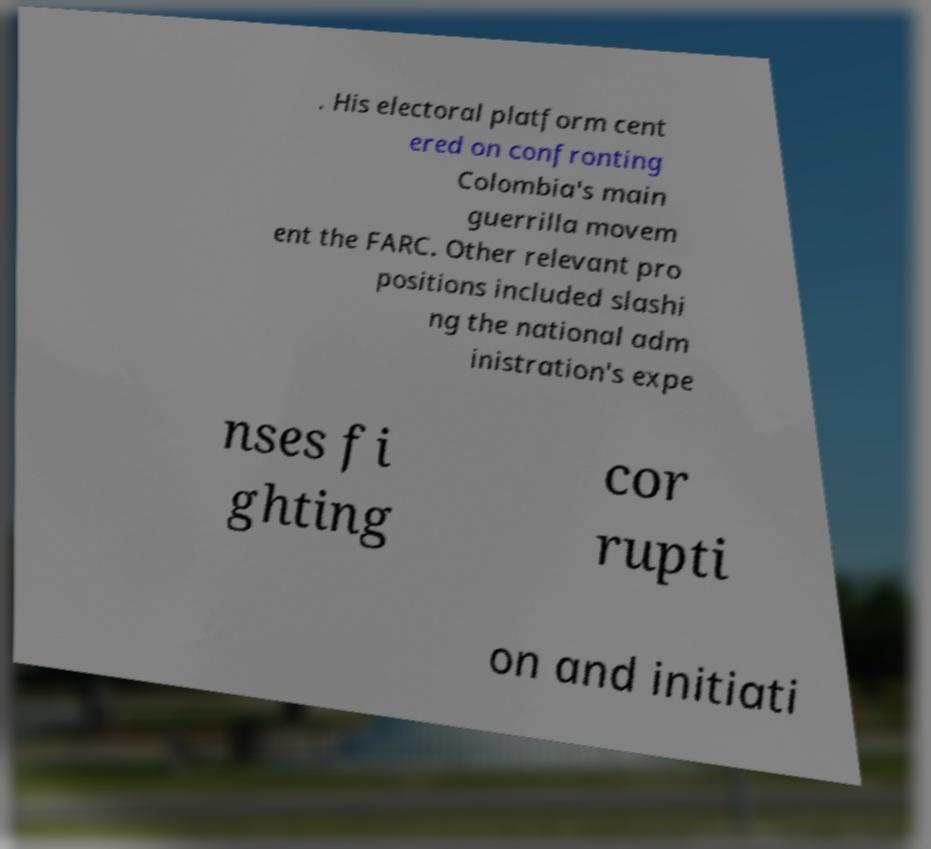I need the written content from this picture converted into text. Can you do that? . His electoral platform cent ered on confronting Colombia's main guerrilla movem ent the FARC. Other relevant pro positions included slashi ng the national adm inistration's expe nses fi ghting cor rupti on and initiati 